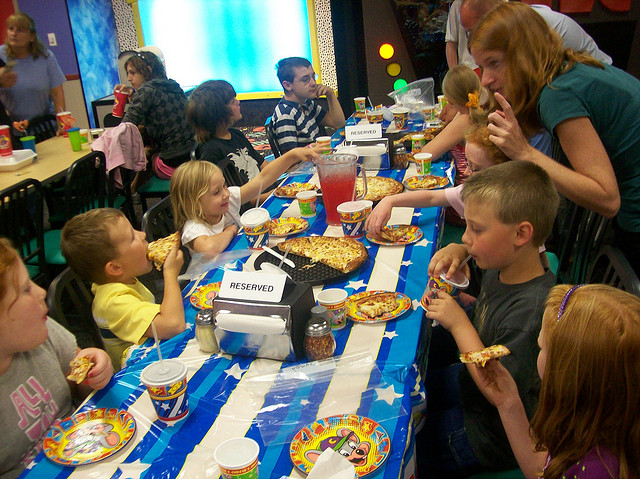Please extract the text content from this image. RESERVEO RESERVED ALL TAX 